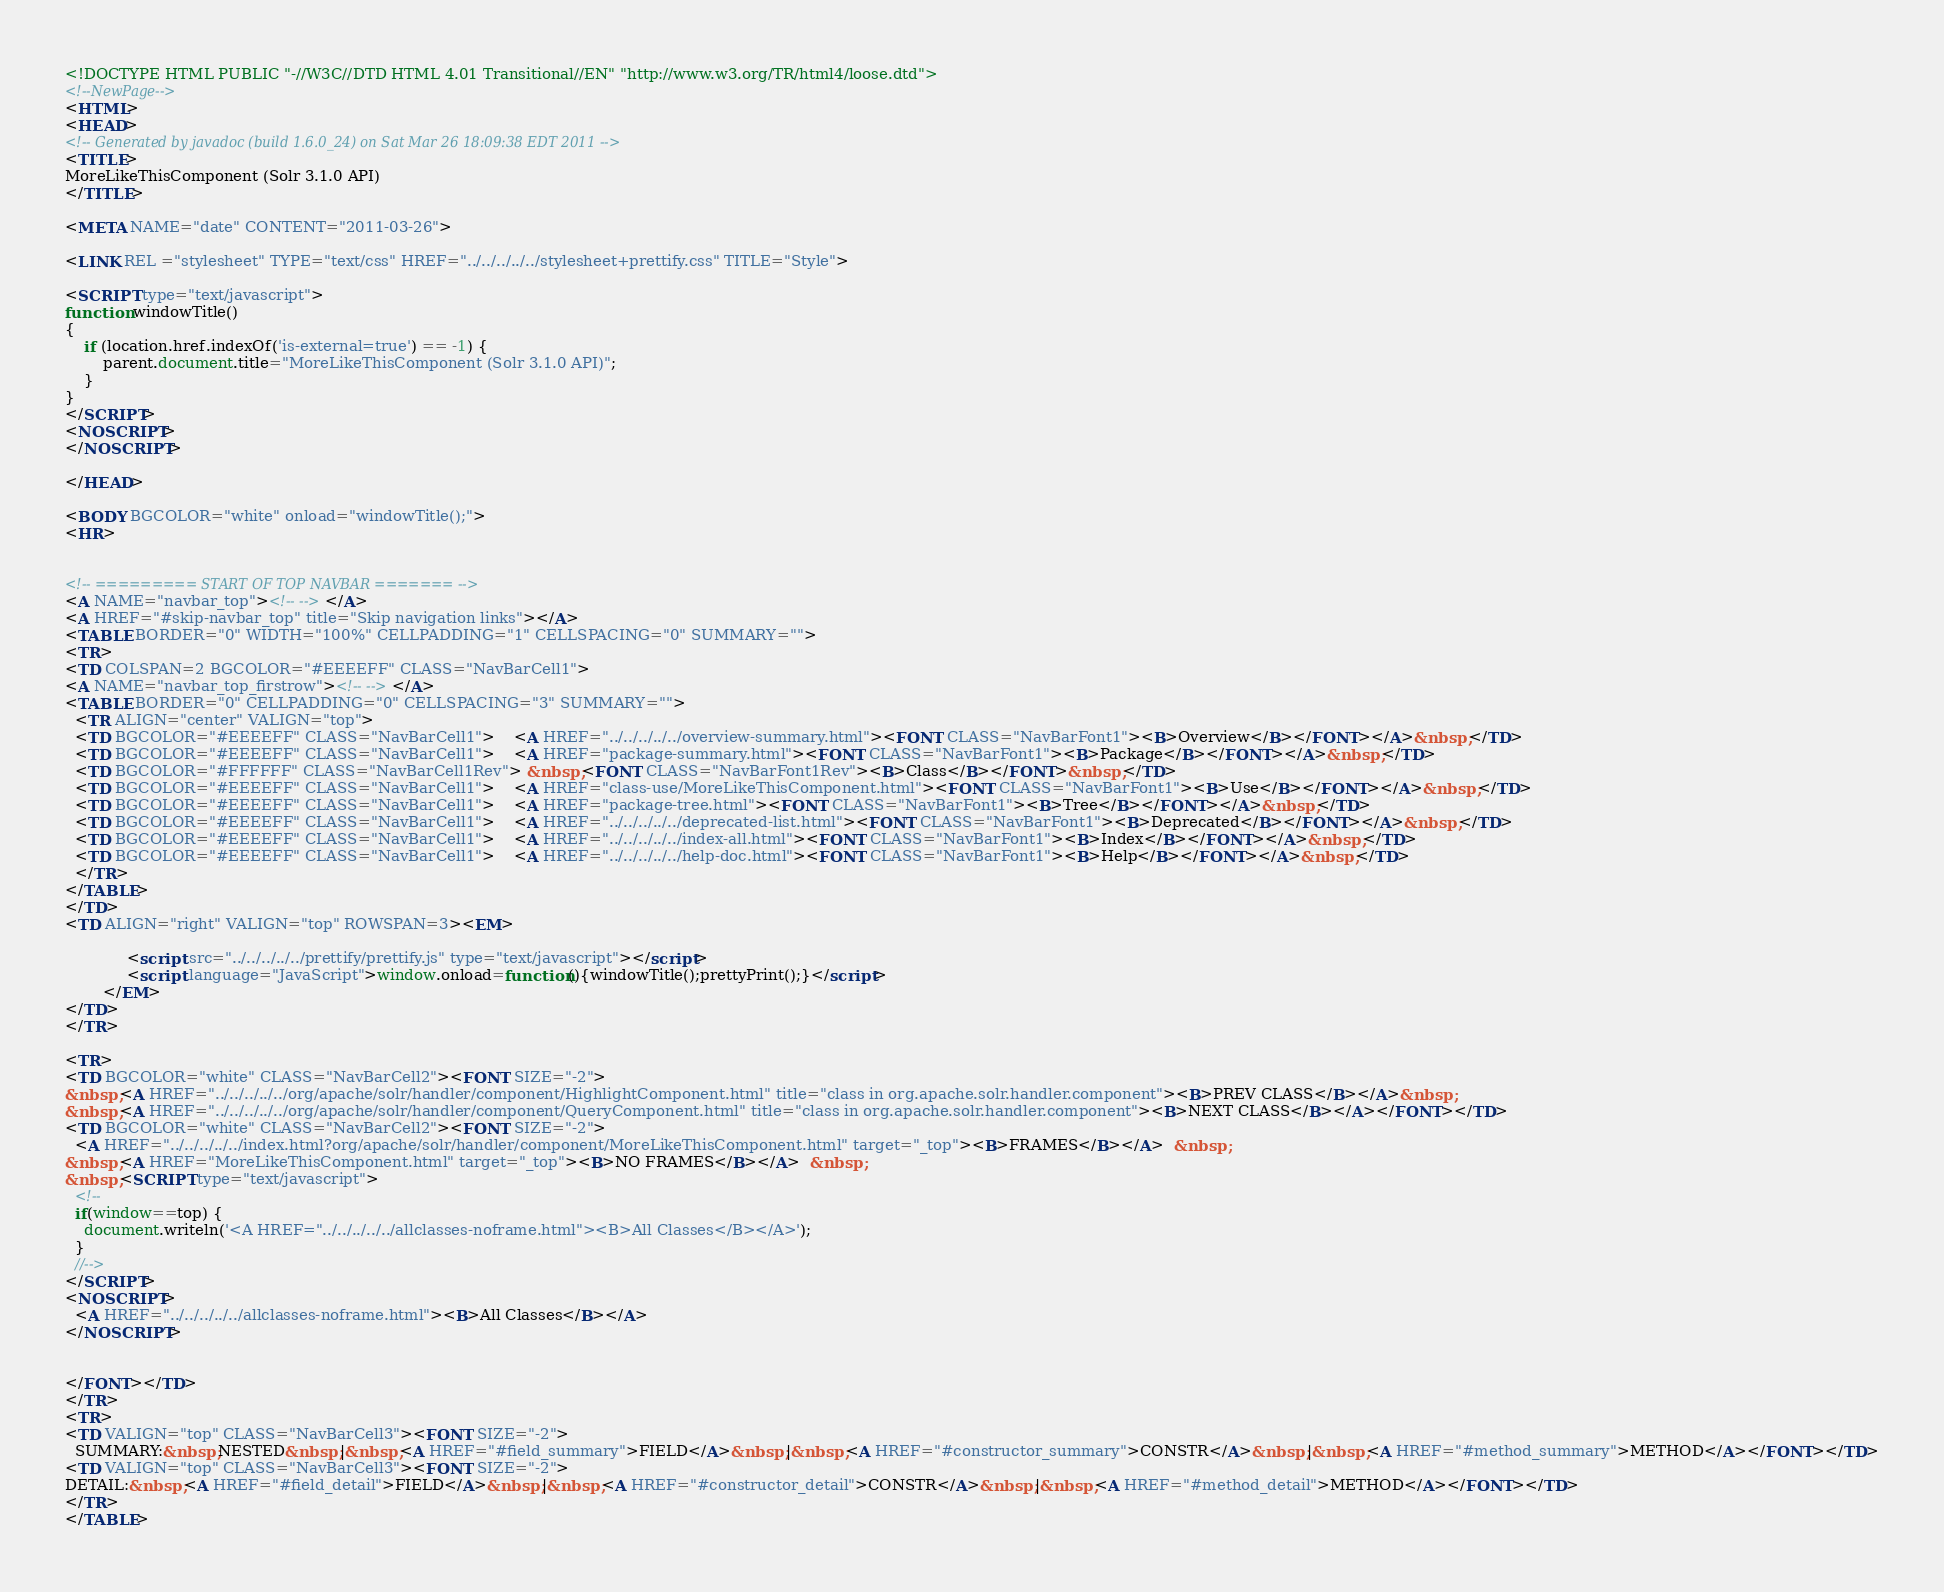<code> <loc_0><loc_0><loc_500><loc_500><_HTML_><!DOCTYPE HTML PUBLIC "-//W3C//DTD HTML 4.01 Transitional//EN" "http://www.w3.org/TR/html4/loose.dtd">
<!--NewPage-->
<HTML>
<HEAD>
<!-- Generated by javadoc (build 1.6.0_24) on Sat Mar 26 18:09:38 EDT 2011 -->
<TITLE>
MoreLikeThisComponent (Solr 3.1.0 API)
</TITLE>

<META NAME="date" CONTENT="2011-03-26">

<LINK REL ="stylesheet" TYPE="text/css" HREF="../../../../../stylesheet+prettify.css" TITLE="Style">

<SCRIPT type="text/javascript">
function windowTitle()
{
    if (location.href.indexOf('is-external=true') == -1) {
        parent.document.title="MoreLikeThisComponent (Solr 3.1.0 API)";
    }
}
</SCRIPT>
<NOSCRIPT>
</NOSCRIPT>

</HEAD>

<BODY BGCOLOR="white" onload="windowTitle();">
<HR>


<!-- ========= START OF TOP NAVBAR ======= -->
<A NAME="navbar_top"><!-- --></A>
<A HREF="#skip-navbar_top" title="Skip navigation links"></A>
<TABLE BORDER="0" WIDTH="100%" CELLPADDING="1" CELLSPACING="0" SUMMARY="">
<TR>
<TD COLSPAN=2 BGCOLOR="#EEEEFF" CLASS="NavBarCell1">
<A NAME="navbar_top_firstrow"><!-- --></A>
<TABLE BORDER="0" CELLPADDING="0" CELLSPACING="3" SUMMARY="">
  <TR ALIGN="center" VALIGN="top">
  <TD BGCOLOR="#EEEEFF" CLASS="NavBarCell1">    <A HREF="../../../../../overview-summary.html"><FONT CLASS="NavBarFont1"><B>Overview</B></FONT></A>&nbsp;</TD>
  <TD BGCOLOR="#EEEEFF" CLASS="NavBarCell1">    <A HREF="package-summary.html"><FONT CLASS="NavBarFont1"><B>Package</B></FONT></A>&nbsp;</TD>
  <TD BGCOLOR="#FFFFFF" CLASS="NavBarCell1Rev"> &nbsp;<FONT CLASS="NavBarFont1Rev"><B>Class</B></FONT>&nbsp;</TD>
  <TD BGCOLOR="#EEEEFF" CLASS="NavBarCell1">    <A HREF="class-use/MoreLikeThisComponent.html"><FONT CLASS="NavBarFont1"><B>Use</B></FONT></A>&nbsp;</TD>
  <TD BGCOLOR="#EEEEFF" CLASS="NavBarCell1">    <A HREF="package-tree.html"><FONT CLASS="NavBarFont1"><B>Tree</B></FONT></A>&nbsp;</TD>
  <TD BGCOLOR="#EEEEFF" CLASS="NavBarCell1">    <A HREF="../../../../../deprecated-list.html"><FONT CLASS="NavBarFont1"><B>Deprecated</B></FONT></A>&nbsp;</TD>
  <TD BGCOLOR="#EEEEFF" CLASS="NavBarCell1">    <A HREF="../../../../../index-all.html"><FONT CLASS="NavBarFont1"><B>Index</B></FONT></A>&nbsp;</TD>
  <TD BGCOLOR="#EEEEFF" CLASS="NavBarCell1">    <A HREF="../../../../../help-doc.html"><FONT CLASS="NavBarFont1"><B>Help</B></FONT></A>&nbsp;</TD>
  </TR>
</TABLE>
</TD>
<TD ALIGN="right" VALIGN="top" ROWSPAN=3><EM>

      		 <script src="../../../../../prettify/prettify.js" type="text/javascript"></script>
      		 <script language="JavaScript">window.onload=function(){windowTitle();prettyPrint();}</script>
      	</EM>
</TD>
</TR>

<TR>
<TD BGCOLOR="white" CLASS="NavBarCell2"><FONT SIZE="-2">
&nbsp;<A HREF="../../../../../org/apache/solr/handler/component/HighlightComponent.html" title="class in org.apache.solr.handler.component"><B>PREV CLASS</B></A>&nbsp;
&nbsp;<A HREF="../../../../../org/apache/solr/handler/component/QueryComponent.html" title="class in org.apache.solr.handler.component"><B>NEXT CLASS</B></A></FONT></TD>
<TD BGCOLOR="white" CLASS="NavBarCell2"><FONT SIZE="-2">
  <A HREF="../../../../../index.html?org/apache/solr/handler/component/MoreLikeThisComponent.html" target="_top"><B>FRAMES</B></A>  &nbsp;
&nbsp;<A HREF="MoreLikeThisComponent.html" target="_top"><B>NO FRAMES</B></A>  &nbsp;
&nbsp;<SCRIPT type="text/javascript">
  <!--
  if(window==top) {
    document.writeln('<A HREF="../../../../../allclasses-noframe.html"><B>All Classes</B></A>');
  }
  //-->
</SCRIPT>
<NOSCRIPT>
  <A HREF="../../../../../allclasses-noframe.html"><B>All Classes</B></A>
</NOSCRIPT>


</FONT></TD>
</TR>
<TR>
<TD VALIGN="top" CLASS="NavBarCell3"><FONT SIZE="-2">
  SUMMARY:&nbsp;NESTED&nbsp;|&nbsp;<A HREF="#field_summary">FIELD</A>&nbsp;|&nbsp;<A HREF="#constructor_summary">CONSTR</A>&nbsp;|&nbsp;<A HREF="#method_summary">METHOD</A></FONT></TD>
<TD VALIGN="top" CLASS="NavBarCell3"><FONT SIZE="-2">
DETAIL:&nbsp;<A HREF="#field_detail">FIELD</A>&nbsp;|&nbsp;<A HREF="#constructor_detail">CONSTR</A>&nbsp;|&nbsp;<A HREF="#method_detail">METHOD</A></FONT></TD>
</TR>
</TABLE></code> 